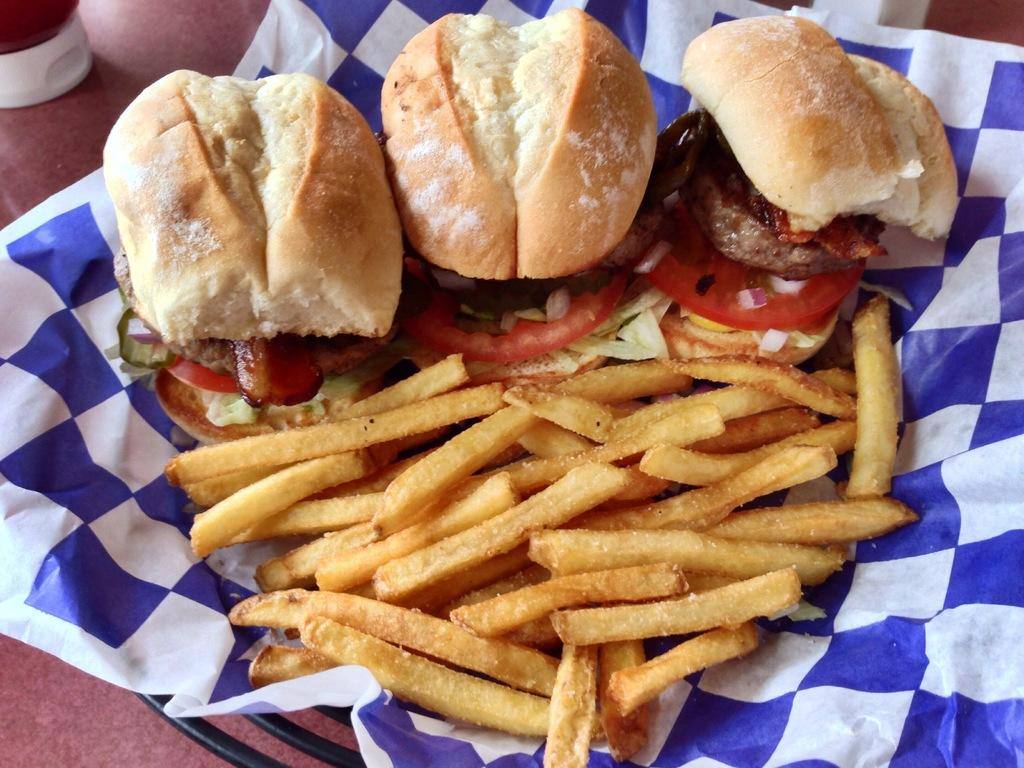What piece of furniture is present in the image? There is a table in the image. What condiment is visible on the table? There is a ketchup bottle on the table. What is located on the table besides the ketchup bottle? There is a bowl on the table. What food items are in the bowl? There are three burgers and french fries in the bowl. Is there anything else in the bowl besides food? Yes, there is a tissue paper in the bowl. What type of trees can be seen in the image? There are no trees present in the image; it features a table with a bowl of food and a ketchup bottle. Can you tell me how many representatives are in the image? There is no mention of representatives in the image; it focuses on a table with food and a ketchup bottle. 